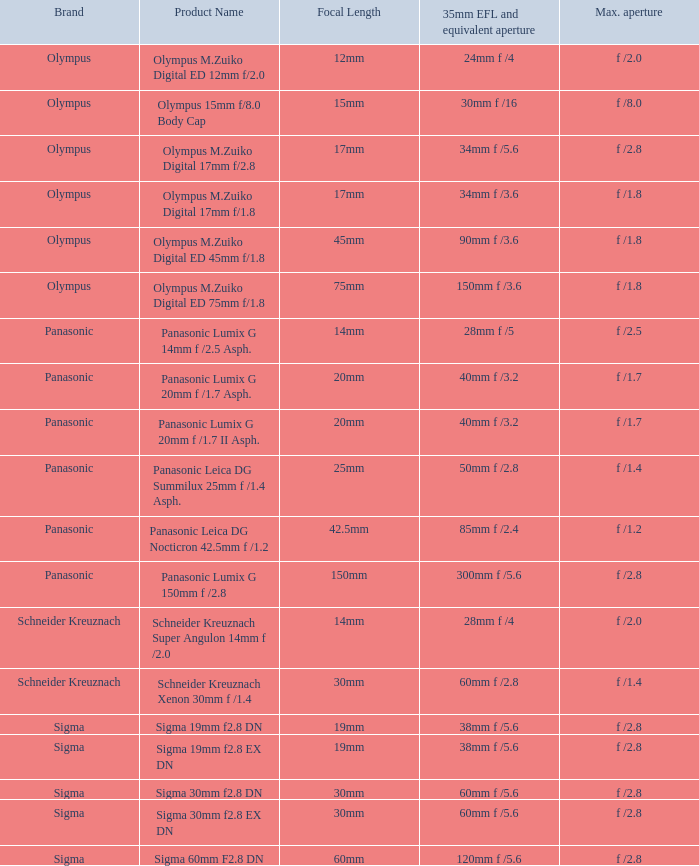What is the 35mm efl and corresponding aperture of the lens(es) with a peak aperture of f / 28mm f /5. Would you mind parsing the complete table? {'header': ['Brand', 'Product Name', 'Focal Length', '35mm EFL and equivalent aperture', 'Max. aperture'], 'rows': [['Olympus', 'Olympus M.Zuiko Digital ED 12mm f/2.0', '12mm', '24mm f /4', 'f /2.0'], ['Olympus', 'Olympus 15mm f/8.0 Body Cap', '15mm', '30mm f /16', 'f /8.0'], ['Olympus', 'Olympus M.Zuiko Digital 17mm f/2.8', '17mm', '34mm f /5.6', 'f /2.8'], ['Olympus', 'Olympus M.Zuiko Digital 17mm f/1.8', '17mm', '34mm f /3.6', 'f /1.8'], ['Olympus', 'Olympus M.Zuiko Digital ED 45mm f/1.8', '45mm', '90mm f /3.6', 'f /1.8'], ['Olympus', 'Olympus M.Zuiko Digital ED 75mm f/1.8', '75mm', '150mm f /3.6', 'f /1.8'], ['Panasonic', 'Panasonic Lumix G 14mm f /2.5 Asph.', '14mm', '28mm f /5', 'f /2.5'], ['Panasonic', 'Panasonic Lumix G 20mm f /1.7 Asph.', '20mm', '40mm f /3.2', 'f /1.7'], ['Panasonic', 'Panasonic Lumix G 20mm f /1.7 II Asph.', '20mm', '40mm f /3.2', 'f /1.7'], ['Panasonic', 'Panasonic Leica DG Summilux 25mm f /1.4 Asph.', '25mm', '50mm f /2.8', 'f /1.4'], ['Panasonic', 'Panasonic Leica DG Nocticron 42.5mm f /1.2', '42.5mm', '85mm f /2.4', 'f /1.2'], ['Panasonic', 'Panasonic Lumix G 150mm f /2.8', '150mm', '300mm f /5.6', 'f /2.8'], ['Schneider Kreuznach', 'Schneider Kreuznach Super Angulon 14mm f /2.0', '14mm', '28mm f /4', 'f /2.0'], ['Schneider Kreuznach', 'Schneider Kreuznach Xenon 30mm f /1.4', '30mm', '60mm f /2.8', 'f /1.4'], ['Sigma', 'Sigma 19mm f2.8 DN', '19mm', '38mm f /5.6', 'f /2.8'], ['Sigma', 'Sigma 19mm f2.8 EX DN', '19mm', '38mm f /5.6', 'f /2.8'], ['Sigma', 'Sigma 30mm f2.8 DN', '30mm', '60mm f /5.6', 'f /2.8'], ['Sigma', 'Sigma 30mm f2.8 EX DN', '30mm', '60mm f /5.6', 'f /2.8'], ['Sigma', 'Sigma 60mm F2.8 DN', '60mm', '120mm f /5.6', 'f /2.8']]} 